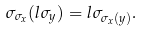Convert formula to latex. <formula><loc_0><loc_0><loc_500><loc_500>\sigma _ { \sigma _ { x } } ( l \sigma _ { y } ) = l \sigma _ { \sigma _ { x } ( y ) } .</formula> 